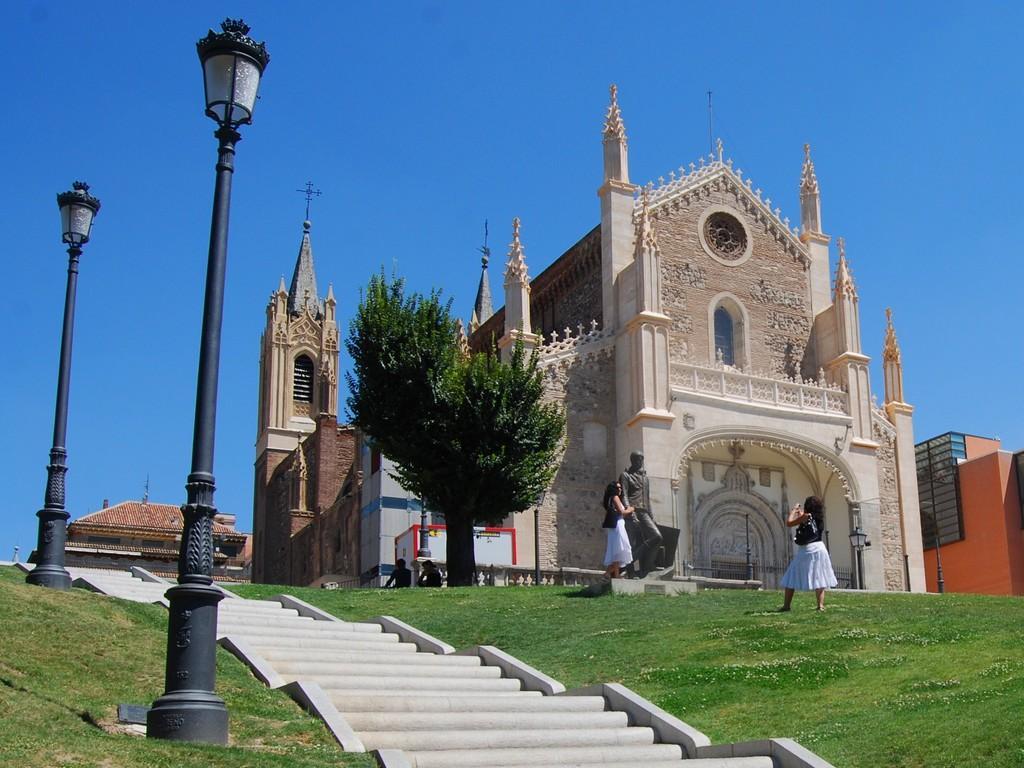Can you describe this image briefly? At the center of the image we can see there is a church, in front of the church there are two girls taking pictures, beside them there is a tree. Beside the tree there are stairs and lamps. In the background there is a sky. 